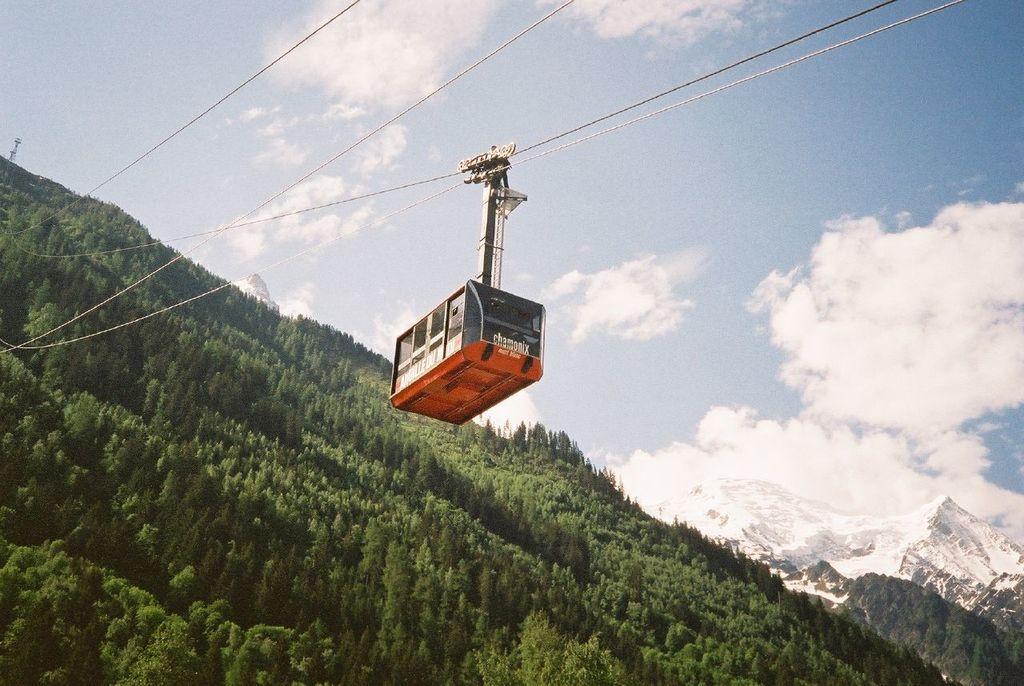Could you give a brief overview of what you see in this image? In the middle of the picture we can see cables and a cable car. Towards left it is looking like a hill covered with trees. In the background towards right there are mountains. In the background and at the top there is sky. 